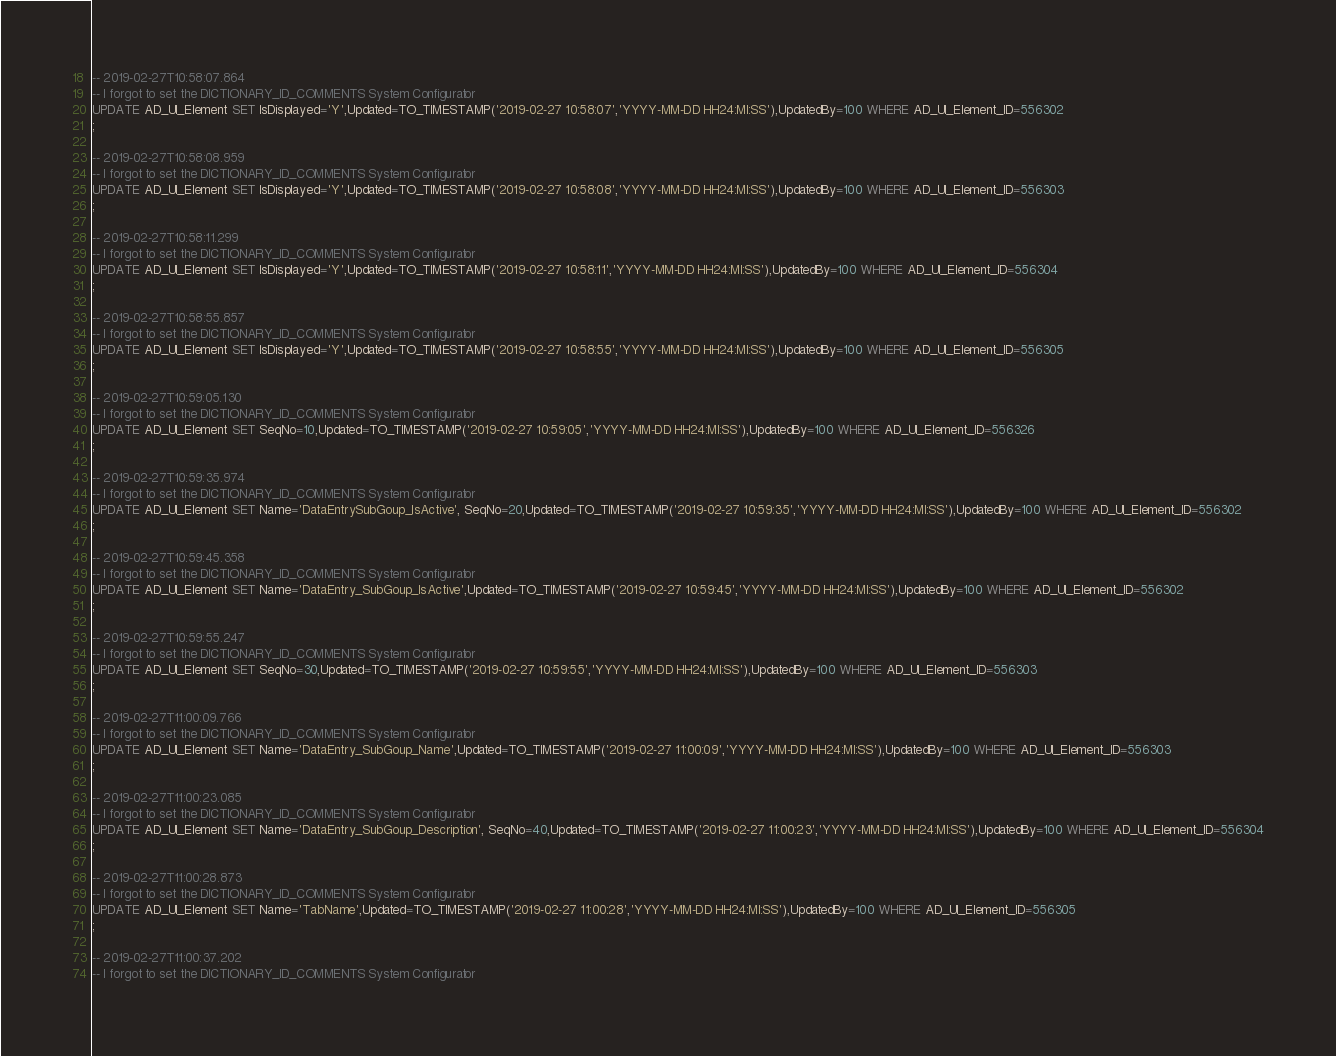<code> <loc_0><loc_0><loc_500><loc_500><_SQL_>-- 2019-02-27T10:58:07.864
-- I forgot to set the DICTIONARY_ID_COMMENTS System Configurator
UPDATE AD_UI_Element SET IsDisplayed='Y',Updated=TO_TIMESTAMP('2019-02-27 10:58:07','YYYY-MM-DD HH24:MI:SS'),UpdatedBy=100 WHERE AD_UI_Element_ID=556302
;

-- 2019-02-27T10:58:08.959
-- I forgot to set the DICTIONARY_ID_COMMENTS System Configurator
UPDATE AD_UI_Element SET IsDisplayed='Y',Updated=TO_TIMESTAMP('2019-02-27 10:58:08','YYYY-MM-DD HH24:MI:SS'),UpdatedBy=100 WHERE AD_UI_Element_ID=556303
;

-- 2019-02-27T10:58:11.299
-- I forgot to set the DICTIONARY_ID_COMMENTS System Configurator
UPDATE AD_UI_Element SET IsDisplayed='Y',Updated=TO_TIMESTAMP('2019-02-27 10:58:11','YYYY-MM-DD HH24:MI:SS'),UpdatedBy=100 WHERE AD_UI_Element_ID=556304
;

-- 2019-02-27T10:58:55.857
-- I forgot to set the DICTIONARY_ID_COMMENTS System Configurator
UPDATE AD_UI_Element SET IsDisplayed='Y',Updated=TO_TIMESTAMP('2019-02-27 10:58:55','YYYY-MM-DD HH24:MI:SS'),UpdatedBy=100 WHERE AD_UI_Element_ID=556305
;

-- 2019-02-27T10:59:05.130
-- I forgot to set the DICTIONARY_ID_COMMENTS System Configurator
UPDATE AD_UI_Element SET SeqNo=10,Updated=TO_TIMESTAMP('2019-02-27 10:59:05','YYYY-MM-DD HH24:MI:SS'),UpdatedBy=100 WHERE AD_UI_Element_ID=556326
;

-- 2019-02-27T10:59:35.974
-- I forgot to set the DICTIONARY_ID_COMMENTS System Configurator
UPDATE AD_UI_Element SET Name='DataEntrySubGoup_IsActive', SeqNo=20,Updated=TO_TIMESTAMP('2019-02-27 10:59:35','YYYY-MM-DD HH24:MI:SS'),UpdatedBy=100 WHERE AD_UI_Element_ID=556302
;

-- 2019-02-27T10:59:45.358
-- I forgot to set the DICTIONARY_ID_COMMENTS System Configurator
UPDATE AD_UI_Element SET Name='DataEntry_SubGoup_IsActive',Updated=TO_TIMESTAMP('2019-02-27 10:59:45','YYYY-MM-DD HH24:MI:SS'),UpdatedBy=100 WHERE AD_UI_Element_ID=556302
;

-- 2019-02-27T10:59:55.247
-- I forgot to set the DICTIONARY_ID_COMMENTS System Configurator
UPDATE AD_UI_Element SET SeqNo=30,Updated=TO_TIMESTAMP('2019-02-27 10:59:55','YYYY-MM-DD HH24:MI:SS'),UpdatedBy=100 WHERE AD_UI_Element_ID=556303
;

-- 2019-02-27T11:00:09.766
-- I forgot to set the DICTIONARY_ID_COMMENTS System Configurator
UPDATE AD_UI_Element SET Name='DataEntry_SubGoup_Name',Updated=TO_TIMESTAMP('2019-02-27 11:00:09','YYYY-MM-DD HH24:MI:SS'),UpdatedBy=100 WHERE AD_UI_Element_ID=556303
;

-- 2019-02-27T11:00:23.085
-- I forgot to set the DICTIONARY_ID_COMMENTS System Configurator
UPDATE AD_UI_Element SET Name='DataEntry_SubGoup_Description', SeqNo=40,Updated=TO_TIMESTAMP('2019-02-27 11:00:23','YYYY-MM-DD HH24:MI:SS'),UpdatedBy=100 WHERE AD_UI_Element_ID=556304
;

-- 2019-02-27T11:00:28.873
-- I forgot to set the DICTIONARY_ID_COMMENTS System Configurator
UPDATE AD_UI_Element SET Name='TabName',Updated=TO_TIMESTAMP('2019-02-27 11:00:28','YYYY-MM-DD HH24:MI:SS'),UpdatedBy=100 WHERE AD_UI_Element_ID=556305
;

-- 2019-02-27T11:00:37.202
-- I forgot to set the DICTIONARY_ID_COMMENTS System Configurator</code> 